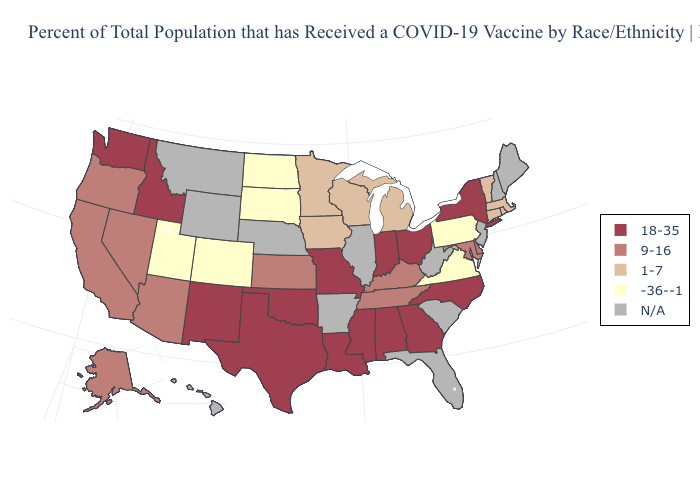What is the lowest value in states that border Pennsylvania?
Be succinct. 9-16. Name the states that have a value in the range N/A?
Keep it brief. Arkansas, Florida, Hawaii, Illinois, Maine, Montana, Nebraska, New Hampshire, New Jersey, South Carolina, West Virginia, Wyoming. What is the highest value in the USA?
Answer briefly. 18-35. Name the states that have a value in the range 18-35?
Give a very brief answer. Alabama, Georgia, Idaho, Indiana, Louisiana, Mississippi, Missouri, New Mexico, New York, North Carolina, Ohio, Oklahoma, Texas, Washington. What is the lowest value in the MidWest?
Concise answer only. -36--1. Name the states that have a value in the range 9-16?
Short answer required. Alaska, Arizona, California, Delaware, Kansas, Kentucky, Maryland, Nevada, Oregon, Tennessee. What is the value of Florida?
Concise answer only. N/A. Among the states that border South Dakota , does North Dakota have the lowest value?
Give a very brief answer. Yes. Which states have the highest value in the USA?
Quick response, please. Alabama, Georgia, Idaho, Indiana, Louisiana, Mississippi, Missouri, New Mexico, New York, North Carolina, Ohio, Oklahoma, Texas, Washington. Name the states that have a value in the range -36--1?
Concise answer only. Colorado, North Dakota, Pennsylvania, South Dakota, Utah, Virginia. What is the value of Nebraska?
Short answer required. N/A. What is the value of Iowa?
Give a very brief answer. 1-7. Among the states that border Mississippi , does Louisiana have the lowest value?
Answer briefly. No. What is the value of Indiana?
Write a very short answer. 18-35. What is the lowest value in states that border Minnesota?
Be succinct. -36--1. 